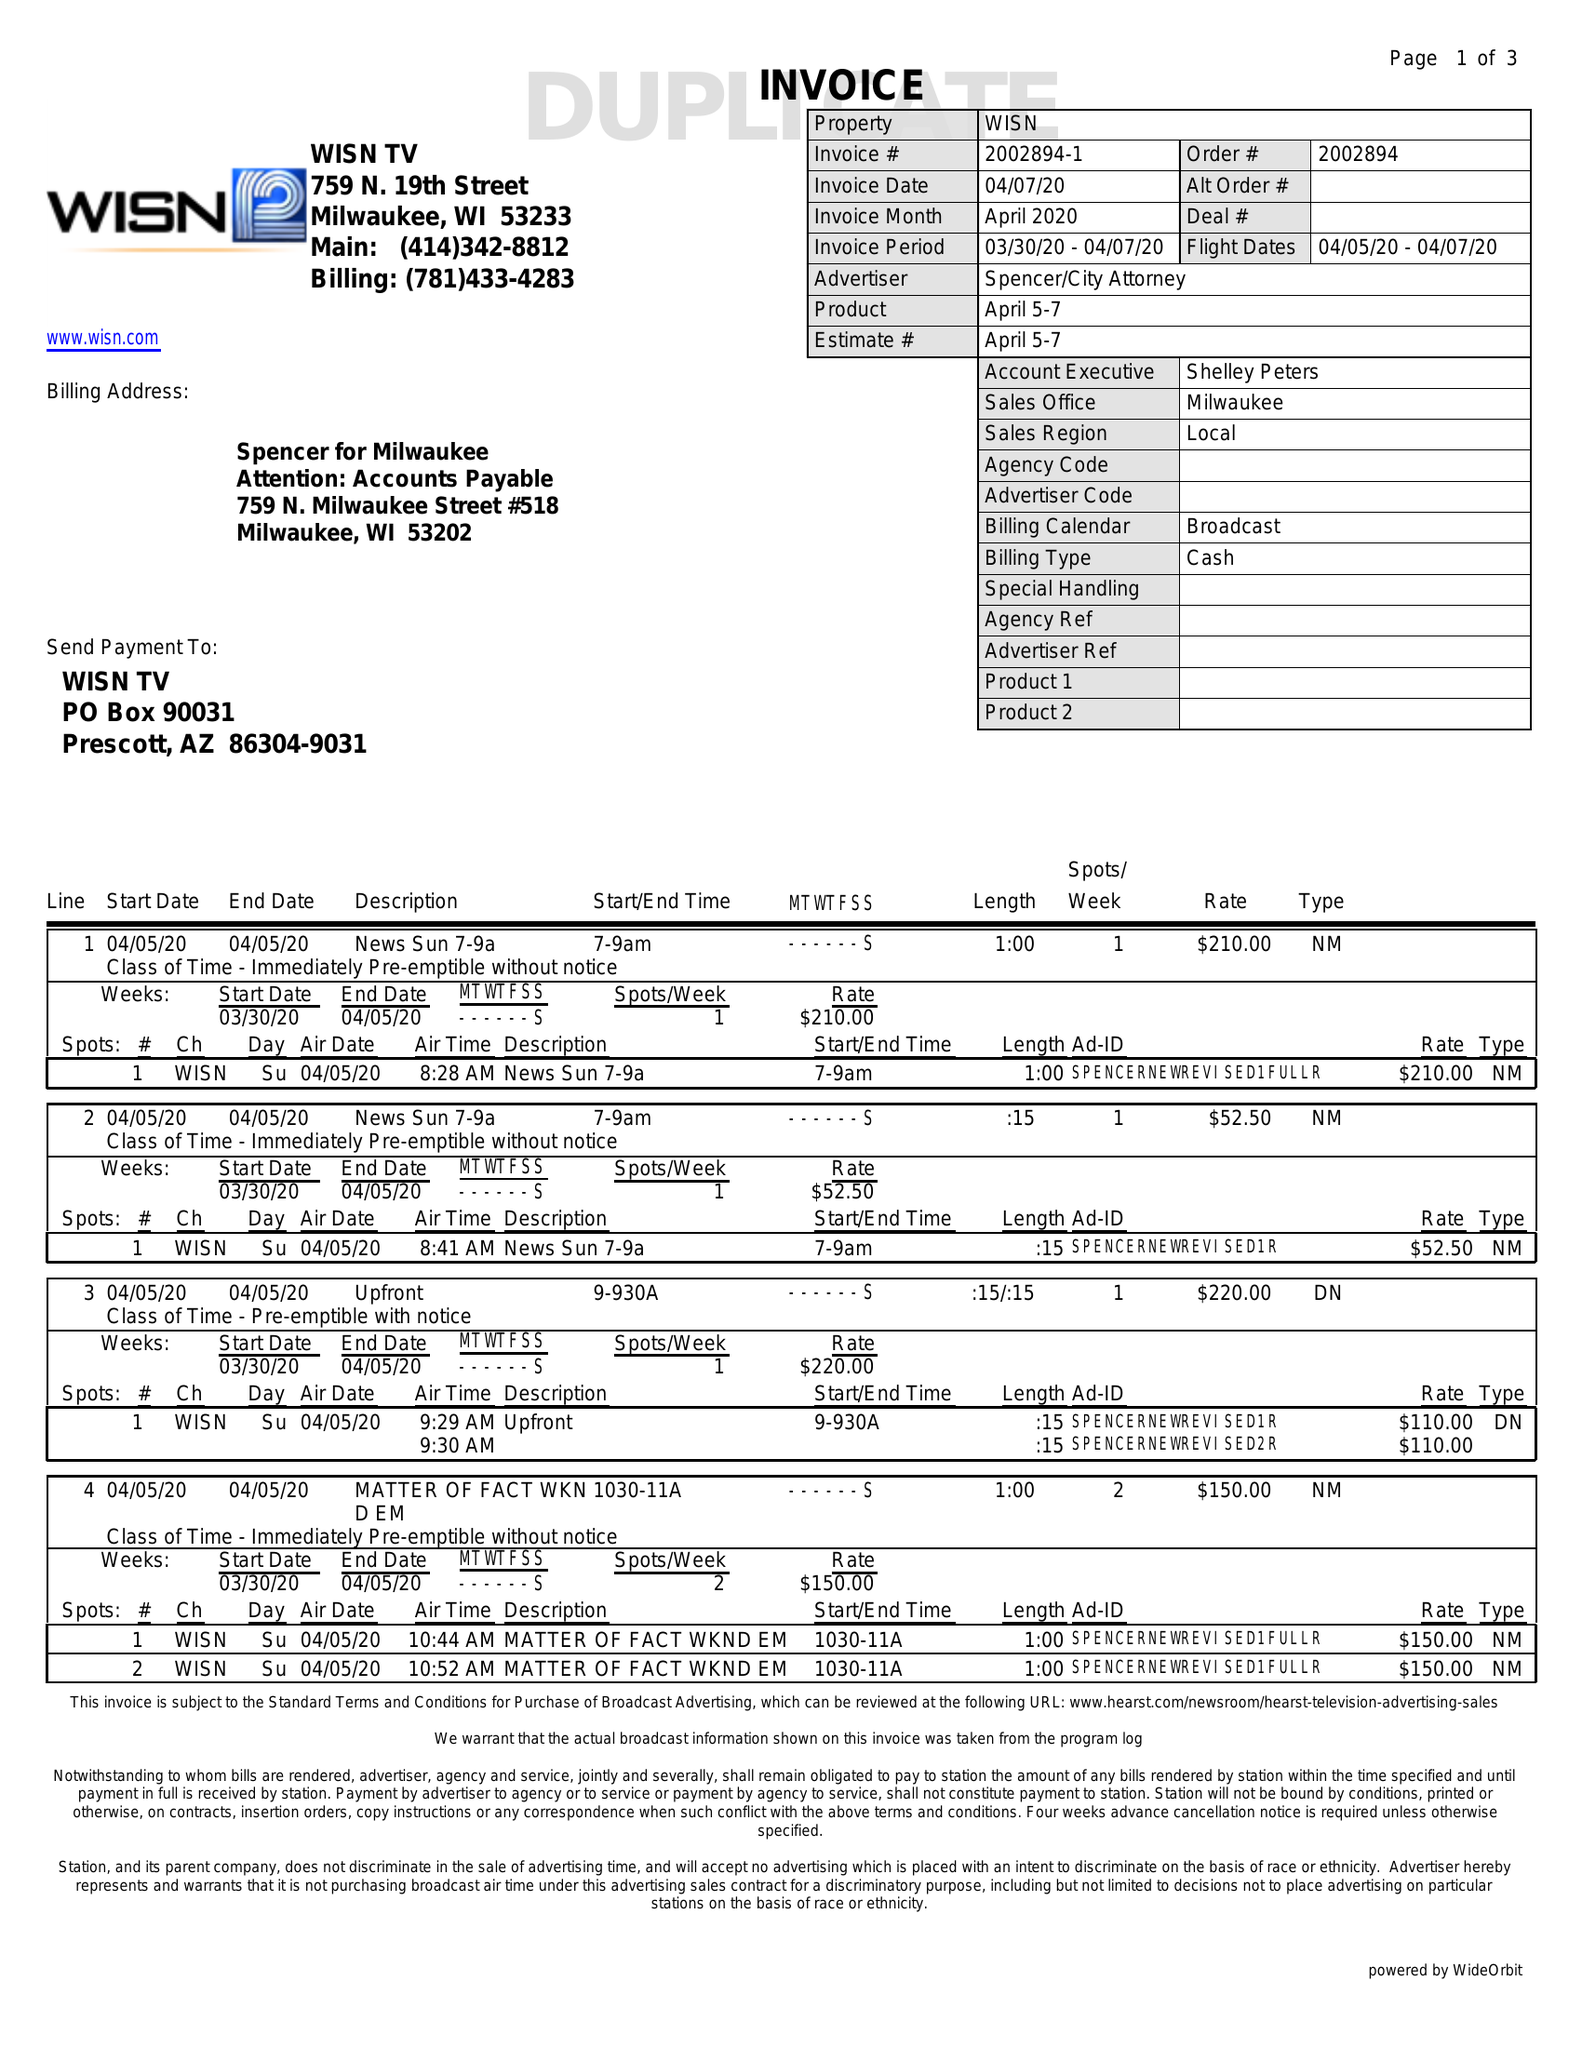What is the value for the flight_to?
Answer the question using a single word or phrase. 04/07/20 